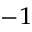<formula> <loc_0><loc_0><loc_500><loc_500>^ { - 1 }</formula> 